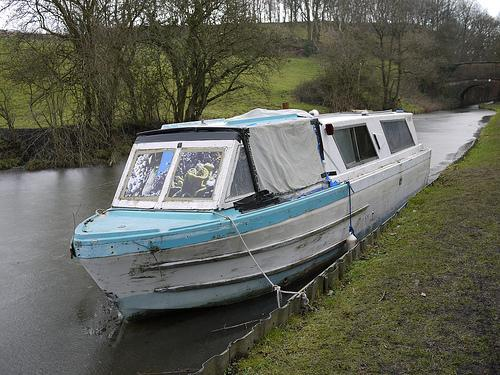How many total objects can be identified in this image? There are a total of 39 distinguishable objects in this image, including the boat, ropes, trees, grass, water, fence, and window. Provide an emotional analysis of the image's contents. The image reflects a calm and serene atmosphere, with elements like the boat docked on the calm water of the river, the green grassy hills, and the leafless trees at the horizon. Give a brief description of the geographical location depicted in the image. The geographical location depicted in the image is a narrow river bed with calm water, green grassy hills, a metal fence along the river, and leafless trees on the horizon. What can you deduce about the environment surrounding the boat? The environment surrounding the boat is serene, with calm water in the river, leafless trees on the horizon, green grass on a hill, and a clear daytime sky. In what way does the trees' current condition reflect the season or climate? The leafless trees on the horizon suggest that the season could be either late autumn or winter, as the trees may have shed their leaves due to colder temperatures. Would you say that this image presents a high quality or low-quality visual experience? Why? The image presents a high-quality visual experience because of the clear, well-defined objects and detailed descriptions of each object in the image, including their positions and sizes. Observe the colorful hot air balloons floating in the daytime sky, and consider their various shapes and patterns. This statement is deceptive, as the image information does not mention any hot air balloons. The declarative sentence gives false information about their colors, shapes, and patterns, further misleading the user into searching for non-existent objects. Look for a group of people having a picnic on the grassy hill, and remember their cheerful expressions and variety of food items. This instruction is deceptive as there is no reference to any people or picnic in the image. Moreover, it uses a declarative sentence to describe false details about their expressions and the food, misleading users who may believe these elements are present in the image. Which side of the fence do you see the adorable squirrel on? Its bushy tail and alert eyes are quite noticeable! This instruction is misleading because there is no mention of a squirrel in the image information. The use of an interrogative sentence and descriptive details about the squirrel's features creates confusion for users trying to find an object that doesn't exist. Can you spot the red umbrella in the corner near the boats? Make sure you take note of its vibrant color and interesting design. This instruction is misleading because there is no mention of a red umbrella in the image information, so it creates confusion for the user trying to find a non-existent object. It also manipulates the user by asking an interrogatory question and giving additional false information about the color and design. Don't miss the beautiful sunset reflected in the calm water of the river, with all its warm hues and serene atmosphere. This instruction is deceptive as it does not correspond to the provided image information. The declarative sentence describes a sunset and its effects on the water that do not exist, leading users to search for a picturesque scene that is not present in the image. Where's the dog playing fetch near the calm water of the river? It seems to be having a really good time! The instruction is misleading because there is no mention of a dog in the provided image information. It uses an interrogative sentence to pique the user's curiosity while falsely creating a scene of a dog playing fetch, causing confusion for the user. 